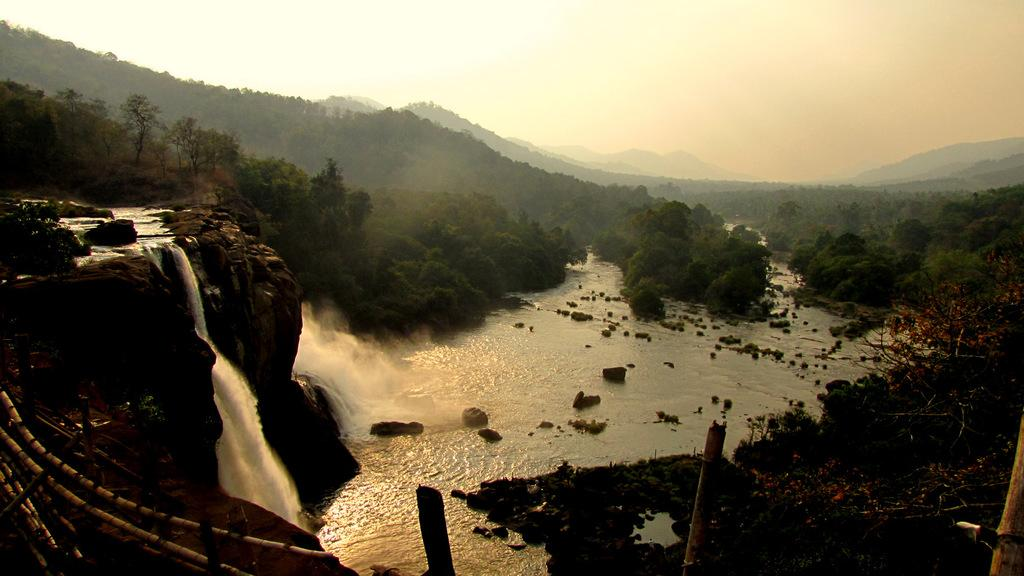What is the main feature of the image? The main feature of the image is a waterfall. What is present in the waterfall? There is water in the image. What type of vegetation can be seen in the image? There are trees in the image. What additional objects are visible in the image? There are ropes and poles visible in the image. What type of glass is being used to capture the waterfall in the image? There is no glass present in the image; it is a photograph or digital representation of the waterfall. How many cards are visible in the image? There are no cards present in the image. 